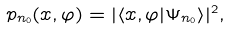Convert formula to latex. <formula><loc_0><loc_0><loc_500><loc_500>p _ { n _ { 0 } } ( x , \varphi ) = | \langle x , \varphi | \Psi _ { n _ { 0 } } \rangle | ^ { 2 } ,</formula> 